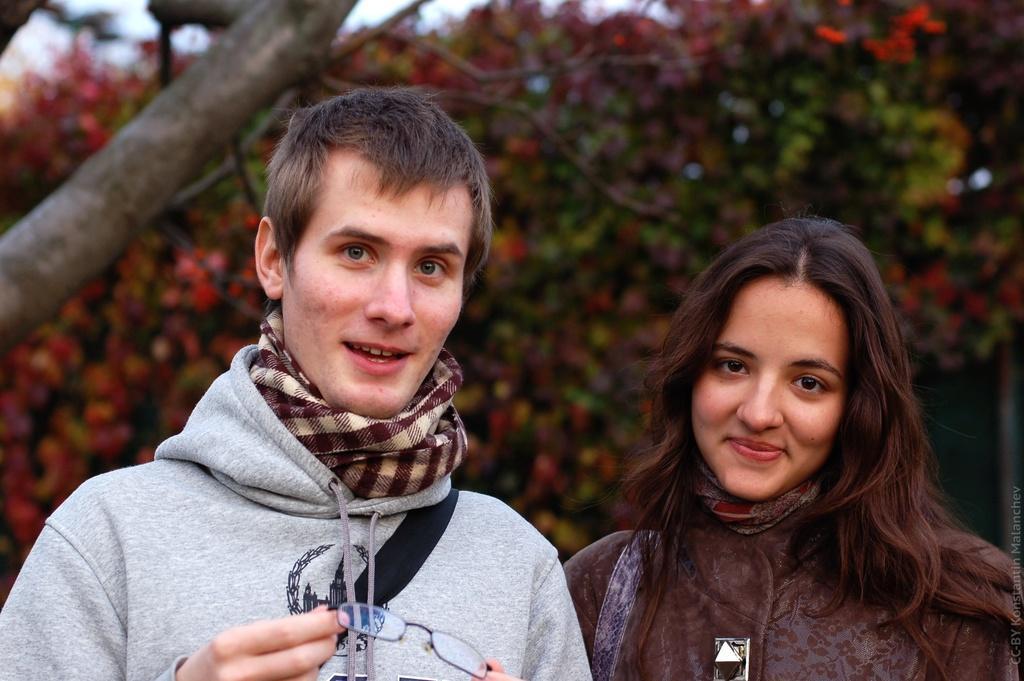Describe this image in one or two sentences. In this image there is a man and a lady, in the background it is blurred. 